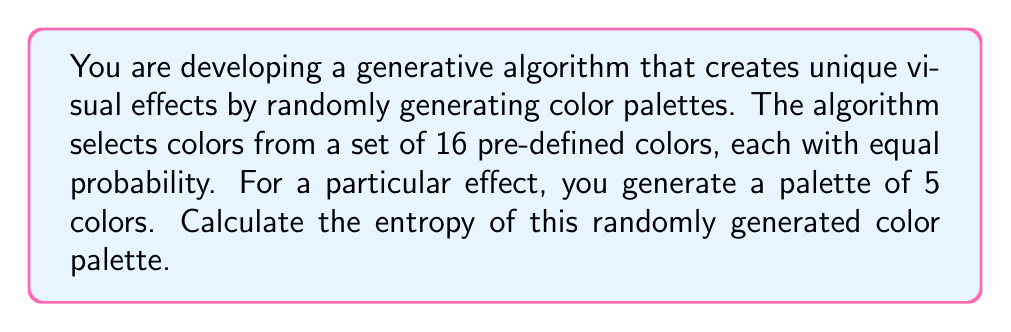Solve this math problem. To calculate the entropy of the randomly generated color palette, we'll follow these steps:

1) First, recall the formula for entropy:
   $$H = -\sum_{i=1}^n p_i \log_2(p_i)$$
   where $p_i$ is the probability of each outcome.

2) In this case, we have 16 colors to choose from, each with equal probability. For each color in our palette of 5 colors:
   $$p_i = \frac{1}{16} = 0.0625$$

3) Since we're selecting 5 colors, and the order matters (as we're creating a specific palette), this is a case of sampling with replacement. The total number of possible outcomes is:
   $$16^5 = 1,048,576$$

4) Each of these outcomes is equally likely, so the probability of any specific palette is:
   $$\frac{1}{16^5} = \frac{1}{1,048,576} \approx 9.54 \times 10^{-7}$$

5) Now, let's calculate the entropy:
   $$\begin{align}
   H &= -\sum_{i=1}^{1,048,576} \frac{1}{1,048,576} \log_2(\frac{1}{1,048,576}) \\
   &= -1,048,576 \cdot \frac{1}{1,048,576} \log_2(\frac{1}{1,048,576}) \\
   &= -\log_2(\frac{1}{1,048,576}) \\
   &= \log_2(1,048,576) \\
   &= \log_2(16^5) \\
   &= 5 \log_2(16) \\
   &= 5 \cdot 4 \\
   &= 20 \text{ bits}
   \end{align}$$

This result makes sense because we're choosing from 16 colors (which require 4 bits to represent) 5 times, so the total information content is 20 bits.
Answer: The entropy of the randomly generated color palette is 20 bits. 